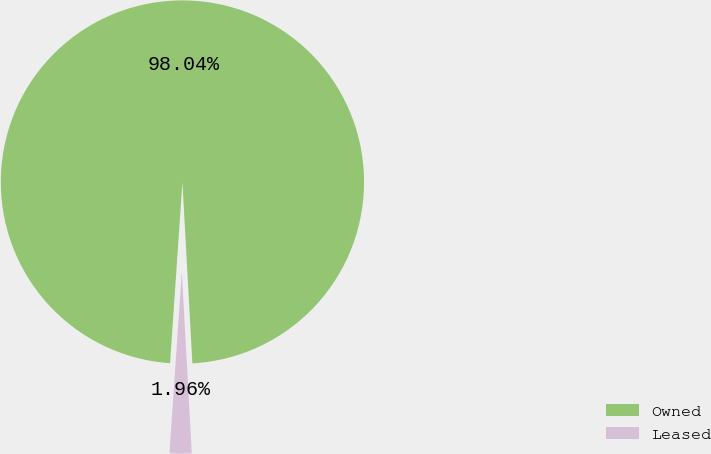<chart> <loc_0><loc_0><loc_500><loc_500><pie_chart><fcel>Owned<fcel>Leased<nl><fcel>98.04%<fcel>1.96%<nl></chart> 